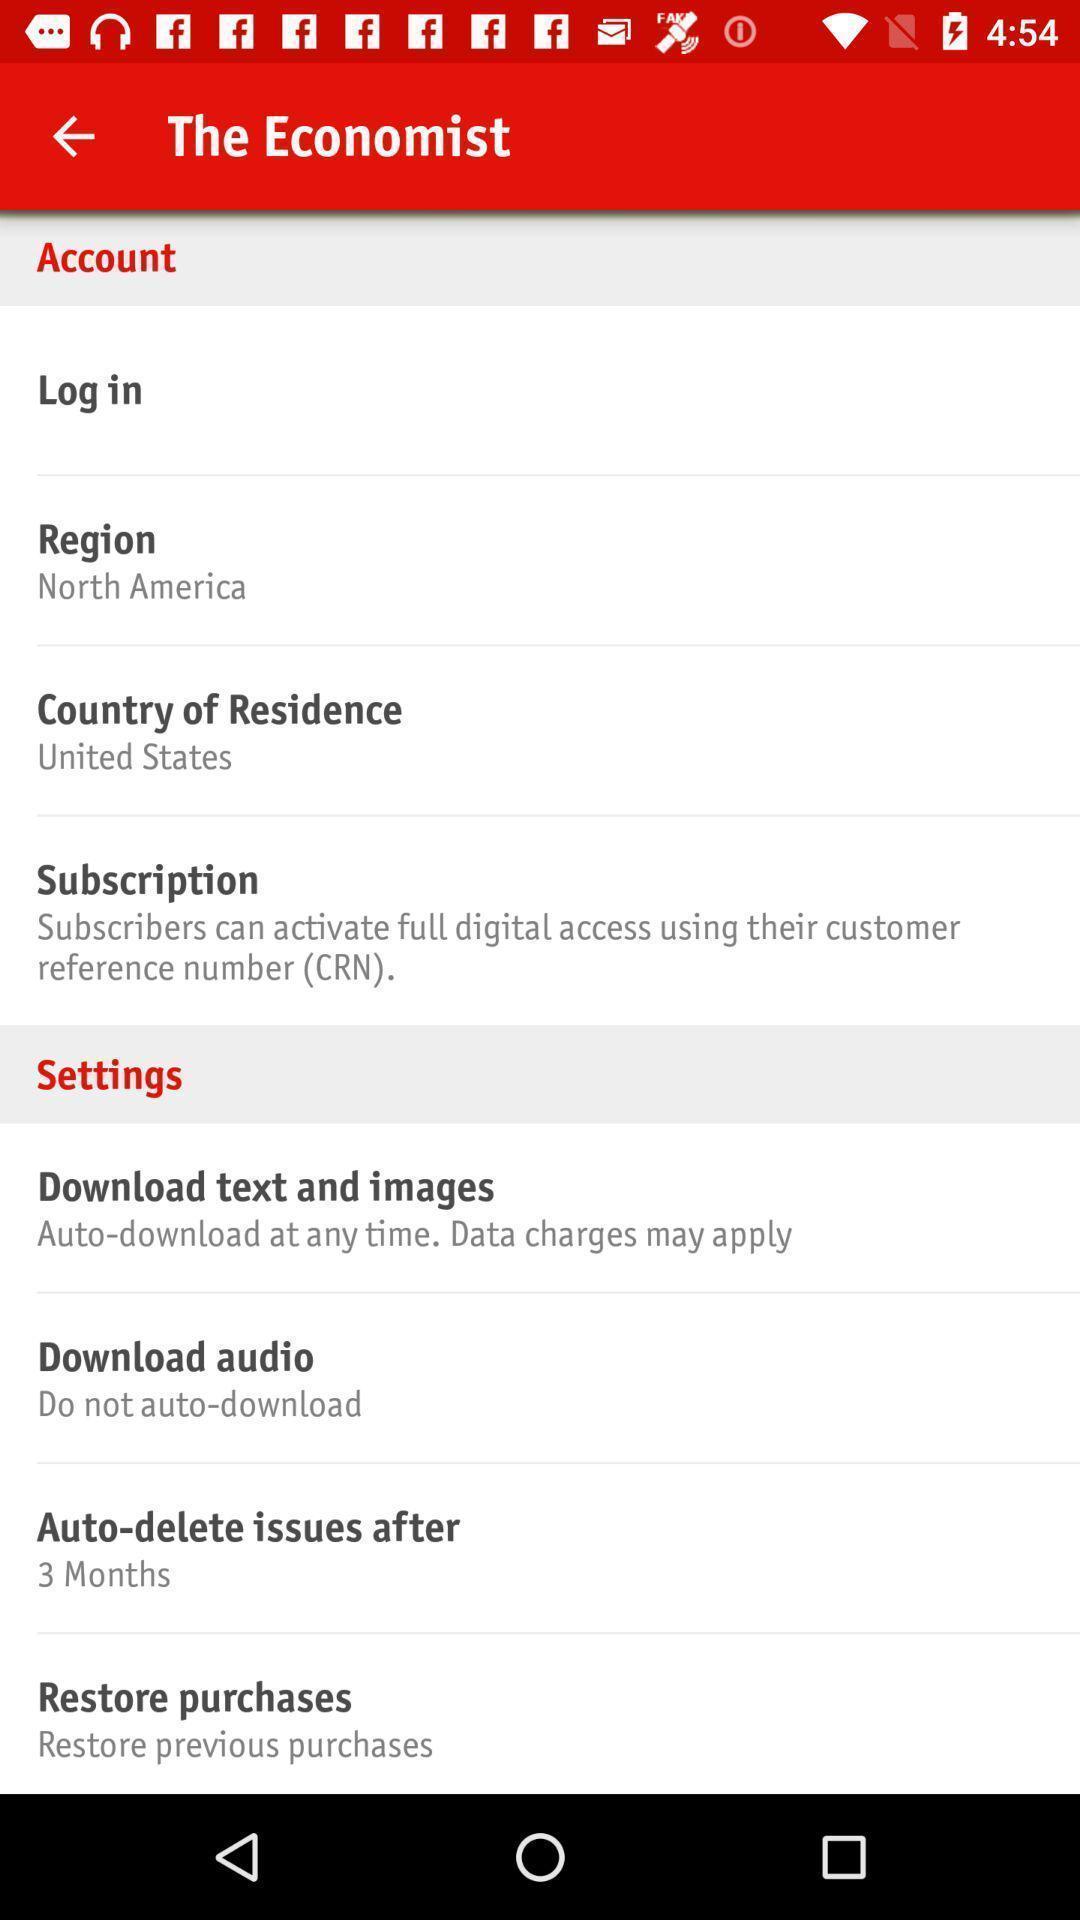What can you discern from this picture? Screen displaying the economist page with list of options. 